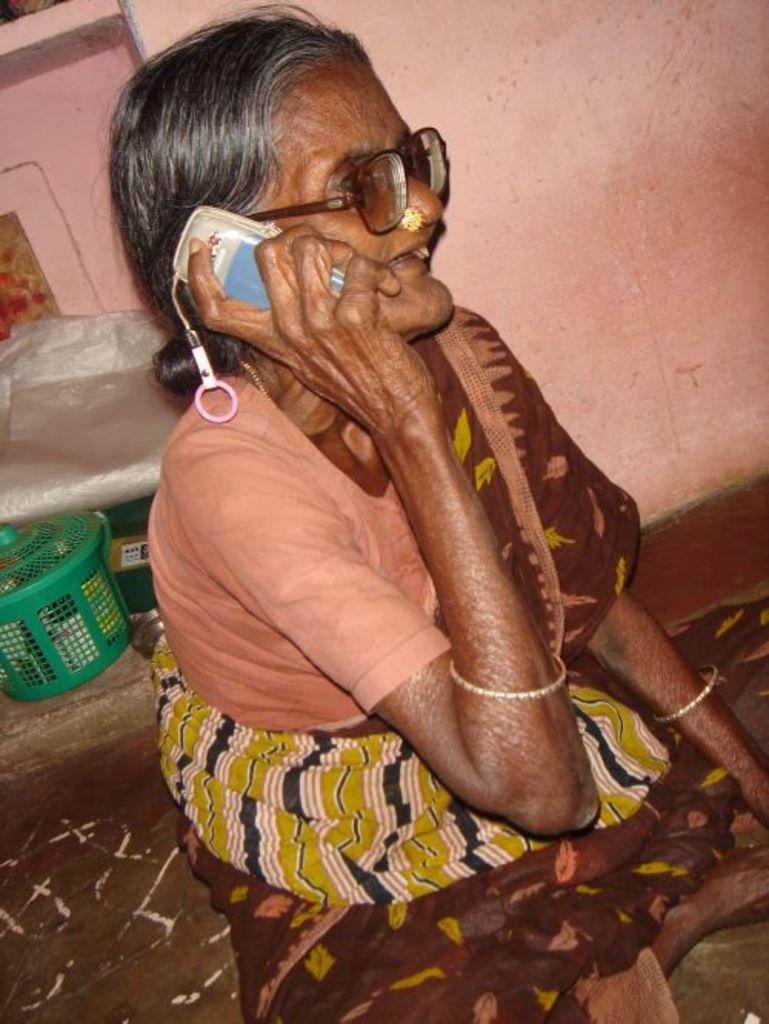Who is the main subject in the image? There is an old woman in the image. What is the woman doing in the image? The woman is sitting on the ground and talking on a mobile phone. What can be seen in the background of the image? There is a brown color wall in the background. What object is located at the bottom side of the image? There is a green basket on the bottom side of the image. What type of blade is being used by the old woman in the image? There is no blade present in the image; the woman is talking on a mobile phone. How does the lead affect the old woman's conversation in the image? There is no mention of lead in the image, and it does not affect the woman's conversation. 